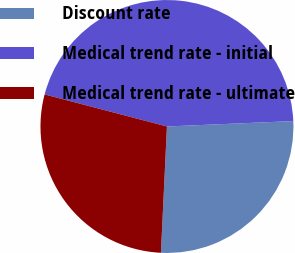Convert chart. <chart><loc_0><loc_0><loc_500><loc_500><pie_chart><fcel>Discount rate<fcel>Medical trend rate - initial<fcel>Medical trend rate - ultimate<nl><fcel>26.44%<fcel>45.24%<fcel>28.32%<nl></chart> 